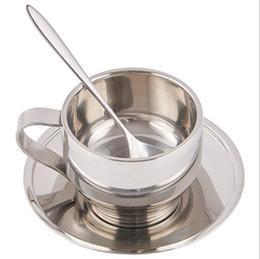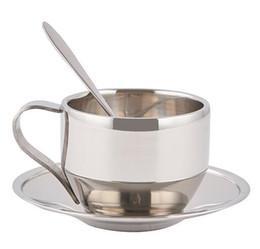The first image is the image on the left, the second image is the image on the right. Examine the images to the left and right. Is the description "The spoon is in the cup in the image on the right." accurate? Answer yes or no. Yes. 